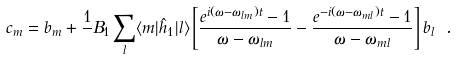<formula> <loc_0><loc_0><loc_500><loc_500>c _ { m } = b _ { m } + \frac { 1 } { } B _ { 1 } \sum _ { l } \langle m | \hat { h } _ { 1 } | l \rangle \left [ \frac { e ^ { i ( \omega - \omega _ { l m } ) t } - 1 } { \omega - \omega _ { l m } } - \frac { e ^ { - i ( \omega - \omega _ { m l } ) t } - 1 } { \omega - \omega _ { m l } } \right ] b _ { l } \ .</formula> 